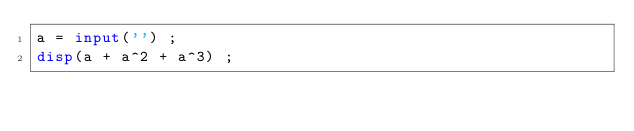Convert code to text. <code><loc_0><loc_0><loc_500><loc_500><_Octave_>a = input('') ;
disp(a + a^2 + a^3) ;</code> 